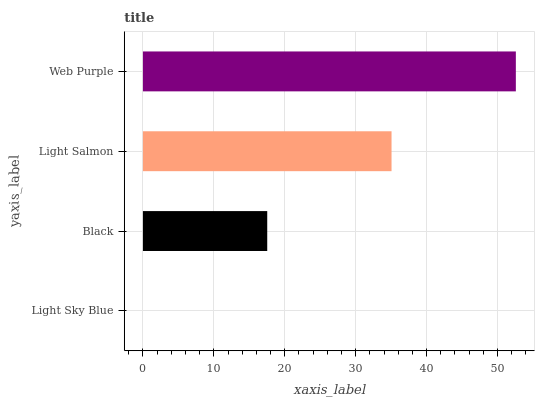Is Light Sky Blue the minimum?
Answer yes or no. Yes. Is Web Purple the maximum?
Answer yes or no. Yes. Is Black the minimum?
Answer yes or no. No. Is Black the maximum?
Answer yes or no. No. Is Black greater than Light Sky Blue?
Answer yes or no. Yes. Is Light Sky Blue less than Black?
Answer yes or no. Yes. Is Light Sky Blue greater than Black?
Answer yes or no. No. Is Black less than Light Sky Blue?
Answer yes or no. No. Is Light Salmon the high median?
Answer yes or no. Yes. Is Black the low median?
Answer yes or no. Yes. Is Light Sky Blue the high median?
Answer yes or no. No. Is Light Salmon the low median?
Answer yes or no. No. 